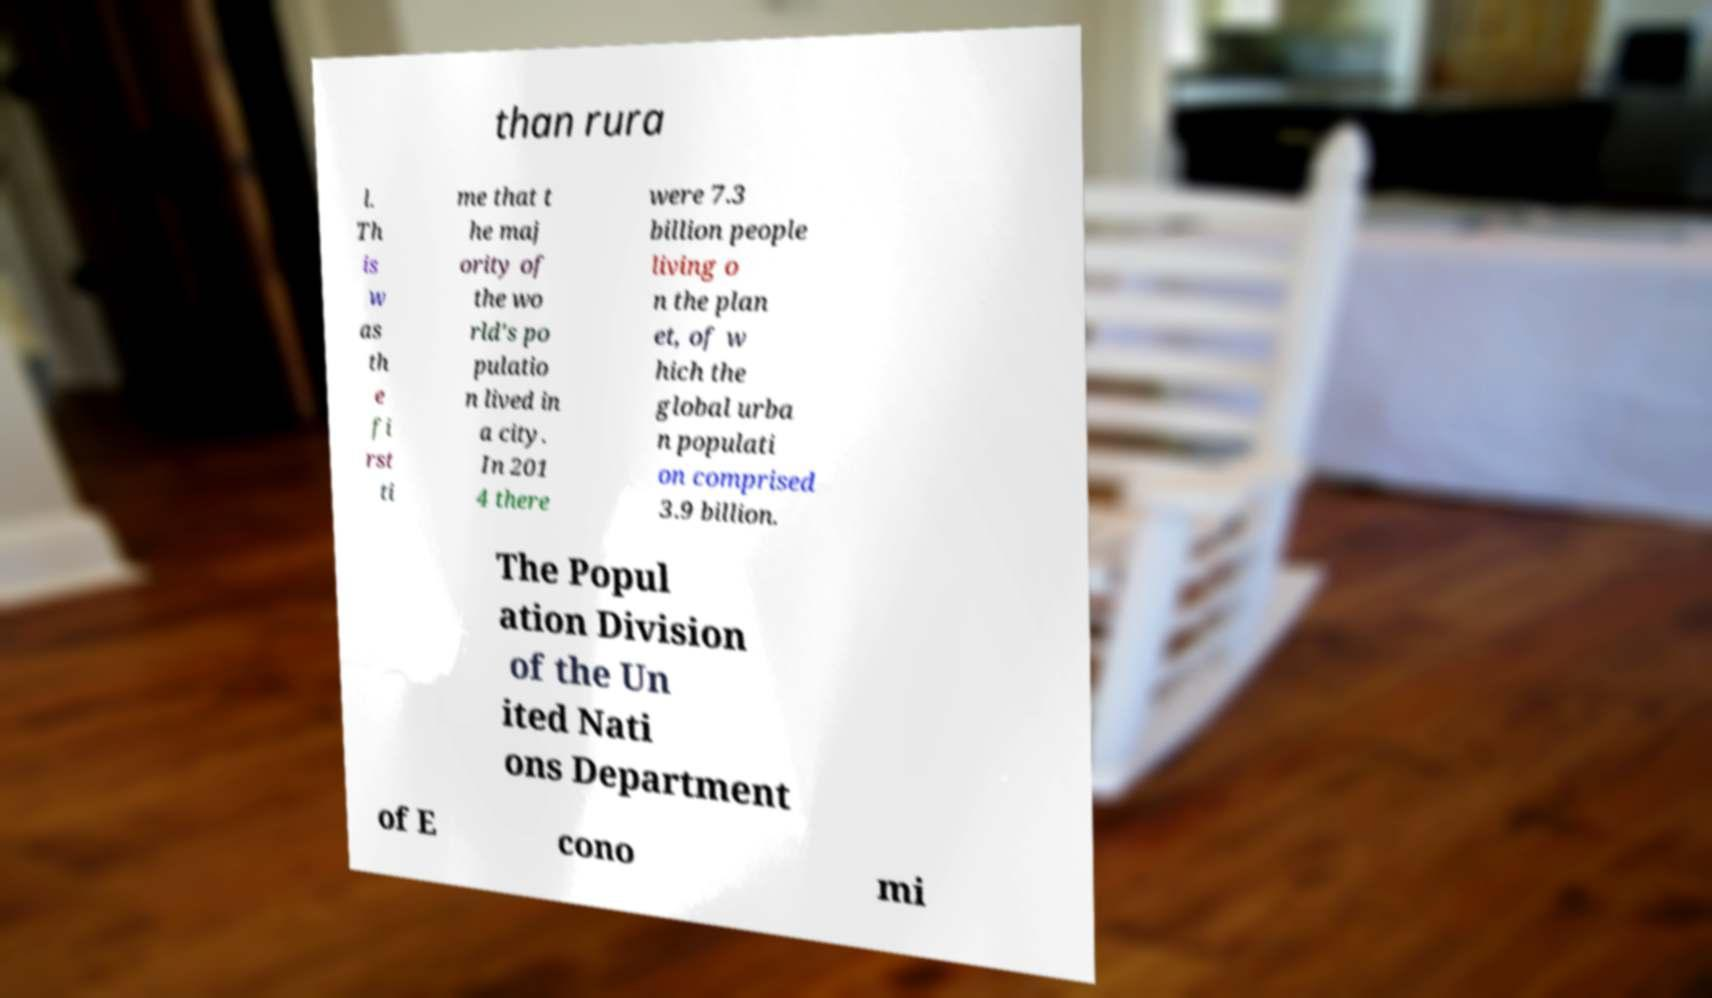There's text embedded in this image that I need extracted. Can you transcribe it verbatim? than rura l. Th is w as th e fi rst ti me that t he maj ority of the wo rld's po pulatio n lived in a city. In 201 4 there were 7.3 billion people living o n the plan et, of w hich the global urba n populati on comprised 3.9 billion. The Popul ation Division of the Un ited Nati ons Department of E cono mi 